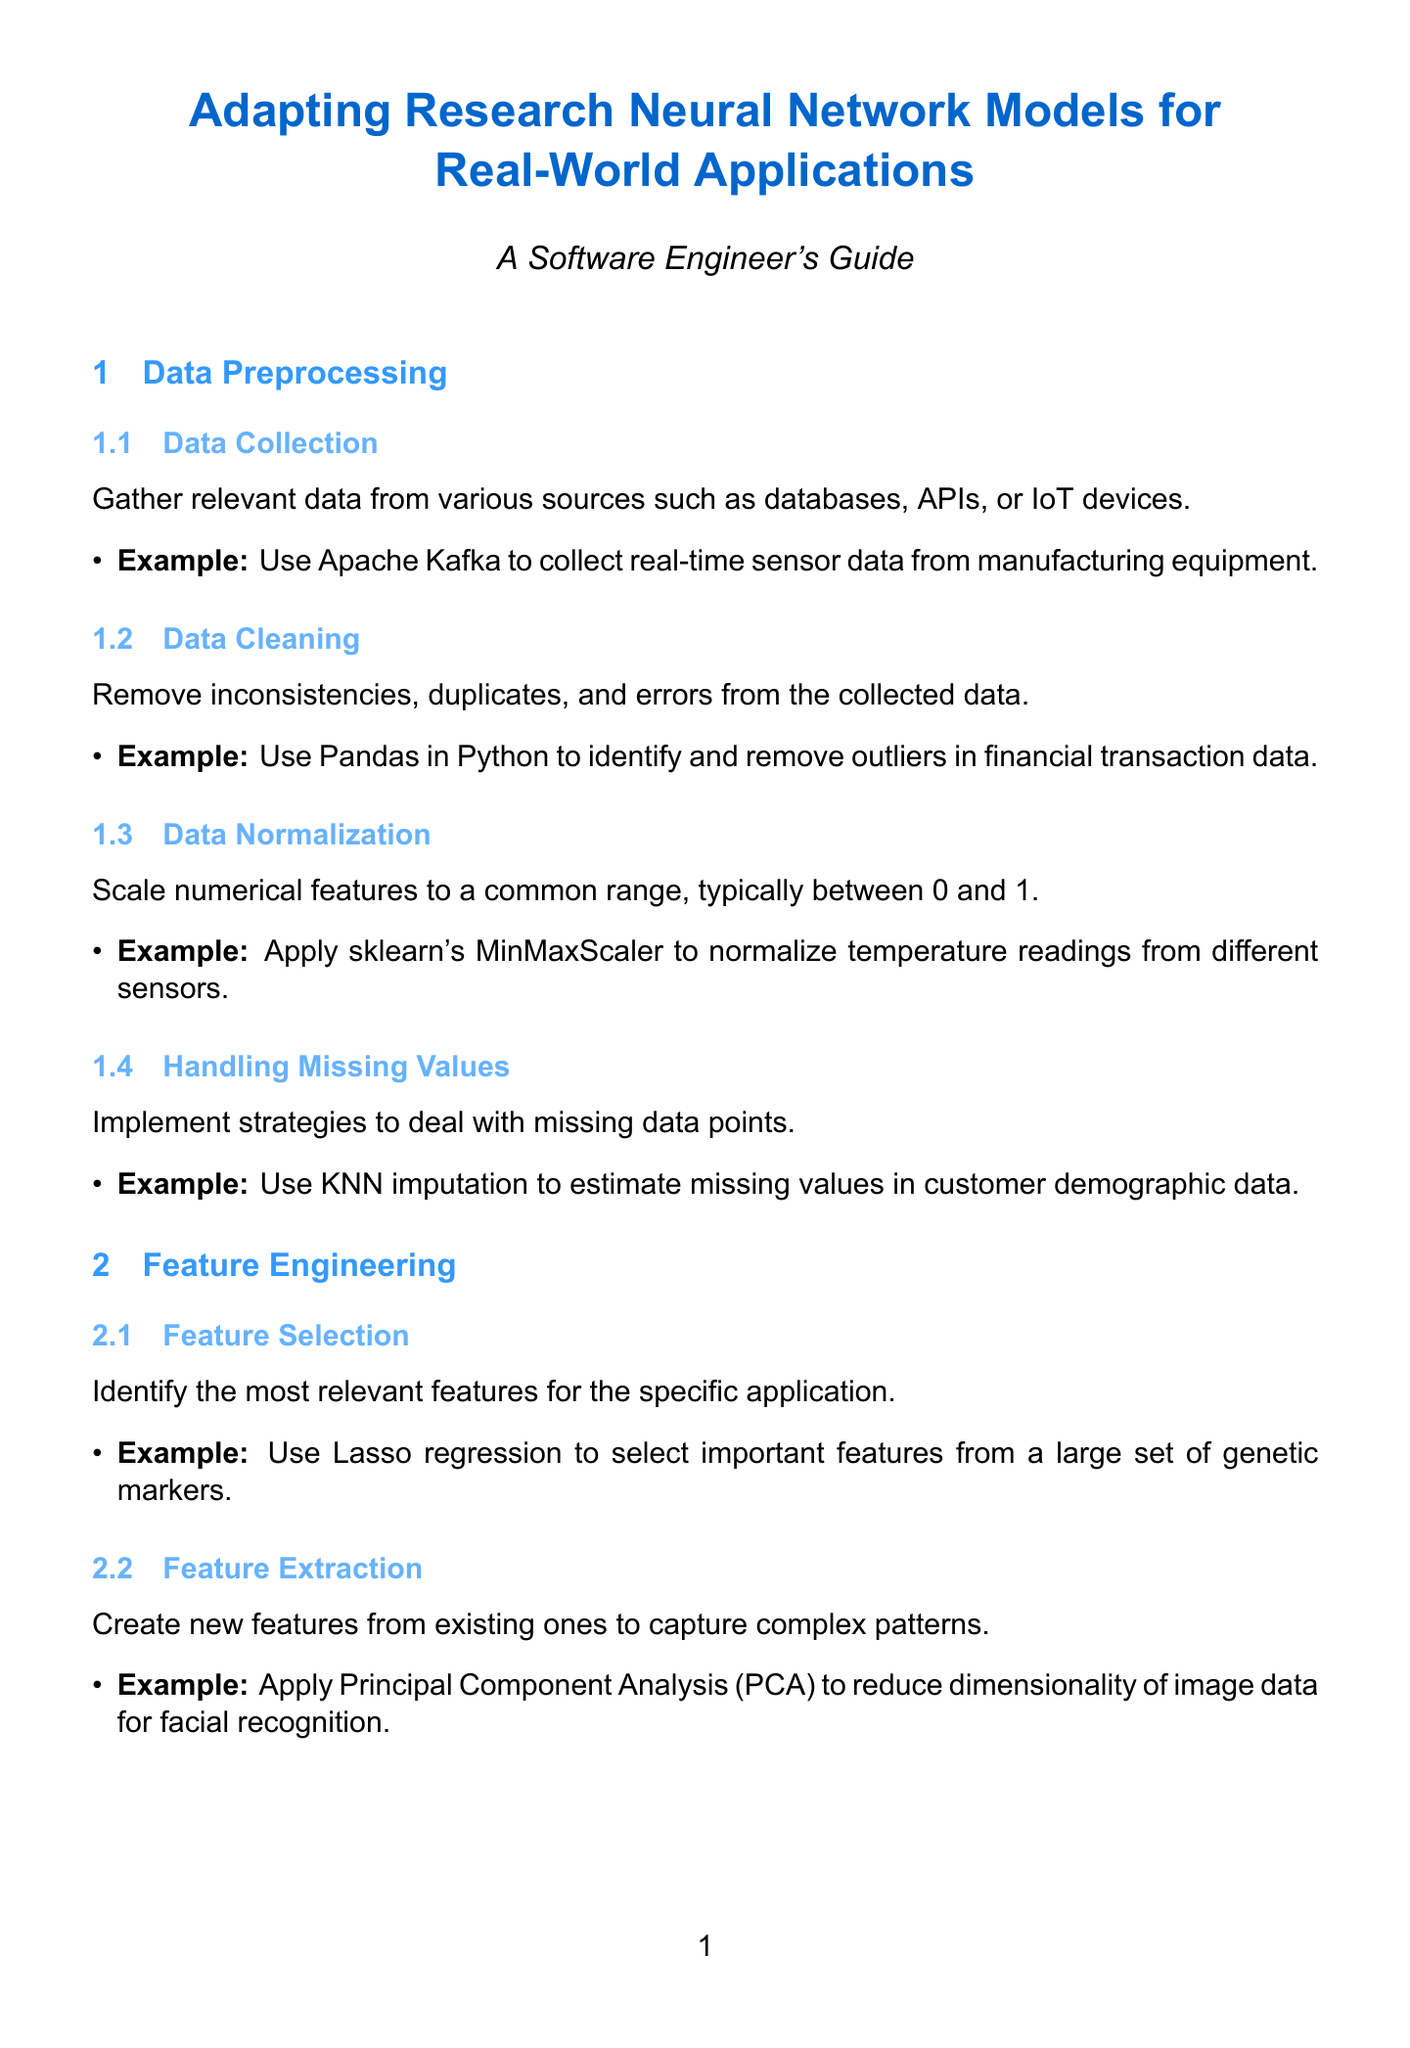What is the title of the document? The title of the document appears at the beginning section, providing an overview of the content.
Answer: Adapting Research Neural Network Models for Real-World Applications What is one example of data collection? The document provides an example of data collection as part of the data preprocessing steps.
Answer: Use Apache Kafka to collect real-time sensor data from manufacturing equipment What technique is used for feature encoding? The document lists a specific method for converting categorical variables into numerical representations.
Answer: One-hot encoding What is the focus of the "Model Pruning and Quantization" step? This section addresses a specific outcome related to model deployment for efficiency.
Answer: Optimize model size and inference speed for deployment on edge devices What evaluation metric is suggested for object detection models? The document includes a particular evaluation metric suitable for assessing specific models.
Answer: Mean Average Precision (mAP) How many steps are listed under Data Preprocessing? The document outlines specific steps involved in data preprocessing, providing a structured approach.
Answer: Four 